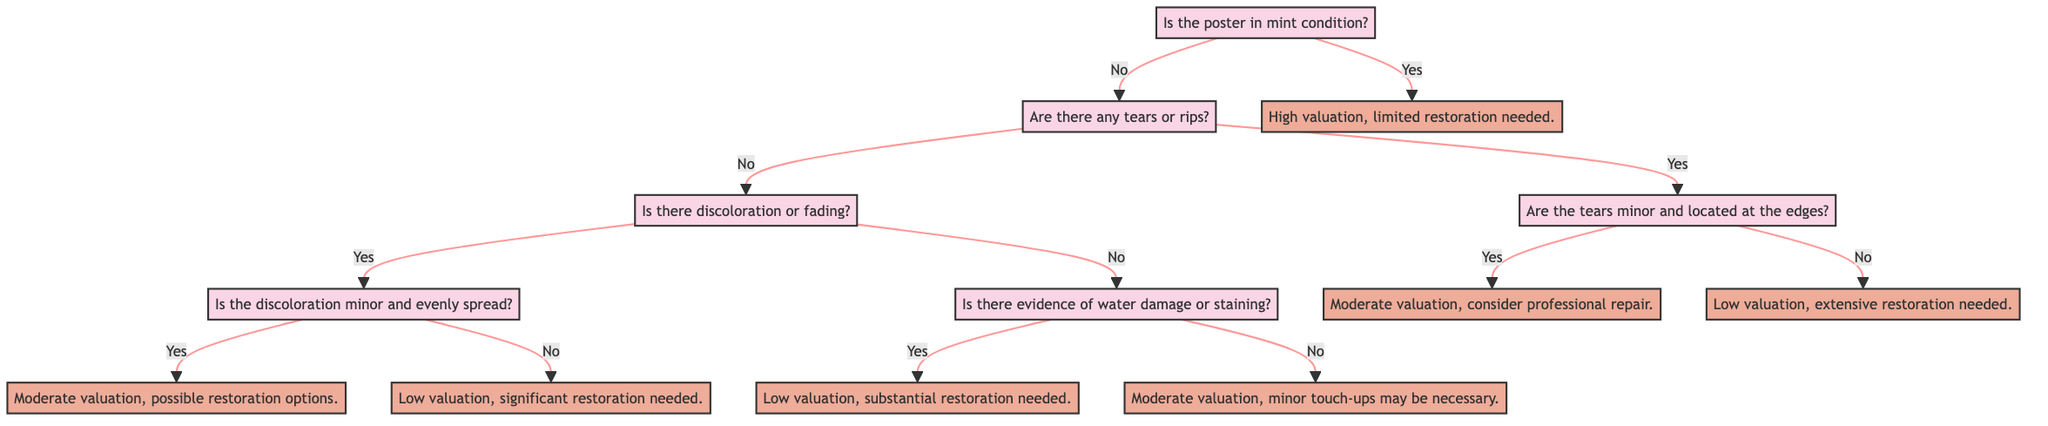What is the first question in the decision tree? The first question in the decision tree is found at the root node, which asks, "Is the poster in mint condition?"
Answer: Is the poster in mint condition? How many main branches are there from the root? From the root node, there are two main branches: one for "Yes" and another for "No." Therefore, there are a total of two main branches.
Answer: 2 What is the action if there are minor tears located at the edges? If there are minor tears located at the edges, the action specified in the diagram is "Moderate valuation, consider professional repair."
Answer: Moderate valuation, consider professional repair What is the action if the poster has evidence of water damage? If there is evidence of water damage, the action described in the diagram is "Low valuation, substantial restoration needed."
Answer: Low valuation, substantial restoration needed If the poster is not in mint condition, are there any actions that lead to a moderate valuation? Yes, if the poster has minor tears at the edges or minor and evenly spread discoloration, both paths lead to a "Moderate valuation." Therefore, there are two actions that can result in moderate valuation.
Answer: Yes, minor tears at edges and minor discoloration What is the second question asked if the poster is not in mint condition? If the poster is not in mint condition, the second question asked is, "Are there any tears or rips?" which branches off from the "No" response of the first question.
Answer: Are there any tears or rips? What happens if the poster has staining but no tears? If the poster has staining and no tears, it moves to the question regarding evidence of water damage. If there is staining, the action will be "Low valuation, substantial restoration needed."
Answer: Low valuation, substantial restoration needed How does the decision tree classify a poster that has significant fading and is not minor or evenly spread? The decision tree classifies such a poster by moving through the nodes to reach the question about discoloration and fading. If it is determined that the fading is significant and not minor or evenly spread, the final action would be "Low valuation, significant restoration needed."
Answer: Low valuation, significant restoration needed 